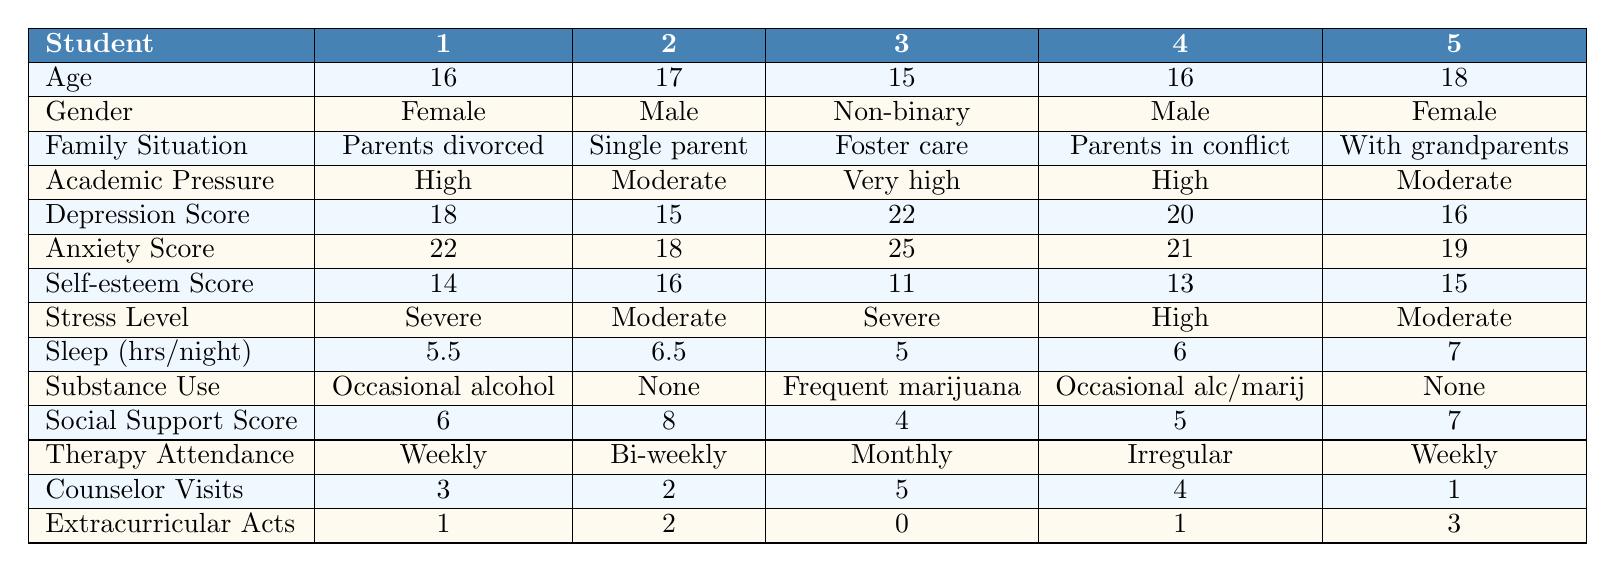What is the age of the student with the highest depression score? The student with the highest depression score is a non-binary student (ID 3) who is 15 years old.
Answer: 15 How many students have a social support score greater than 6? The students with social support scores greater than 6 are the male student (ID 2), and the female student (ID 5). That's a total of 2 students.
Answer: 2 What is the average self-esteem score of the students in the table? The self-esteem scores are 14, 16, 11, 13, and 15. The sum is 69, and there are 5 students, so the average self-esteem score is 69/5 = 13.8.
Answer: 13.8 Is there a student who attends therapy weekly and has a stress level of 'Severe'? Yes, the female student (ID 1) attends therapy weekly and has a severe stress level.
Answer: Yes What is the difference in sleep hours between the student with the lowest and highest self-esteem scores? The student with the lowest self-esteem score (ID 3) sleeps 5 hours per night, while the highest self-esteem score (ID 2) sleeps 6.5 hours. The difference in sleep hours is 6.5 - 5 = 1.5 hours.
Answer: 1.5 Which student's family situation reflects the highest level of academic pressure? The non-binary student (ID 3) is in foster care and has the highest level of academic pressure, rated as "Very high."
Answer: ID 3 How many students report using substances occasionally or frequently? The students with substance use reported as "Occasional alcohol" (ID 1) and "Occasional alcohol and marijuana" (ID 4) are 2 students. The non-binary student (ID 3) uses "Frequent marijuana," bringing the total to 3 students.
Answer: 3 What is the highest anxiety score among the students listed? The highest anxiety score in the table belongs to the non-binary student (ID 3), which is 25.
Answer: 25 Which student has the highest academic pressure level? The non-binary student (ID 3) has the highest academic pressure level, rated as "Very high."
Answer: ID 3 Do any students have a social support score of less than 5? Yes, the non-binary student (ID 3) has a social support score of 4.
Answer: Yes What is the average depression score of male students? The male students' depression scores are 18 (ID 1), 15 (ID 2), and 20 (ID 4), giving a total of 53. With 3 male students, the average is 53/3 = 17.67.
Answer: 17.67 